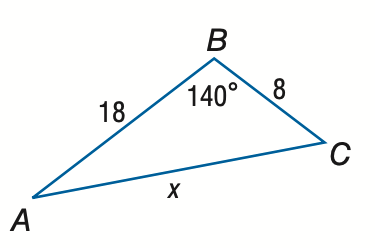Answer the mathemtical geometry problem and directly provide the correct option letter.
Question: Find x. Round to the nearest tenth.
Choices: A: 12.3 B: 24.7 C: 49.3 D: 74.0 B 